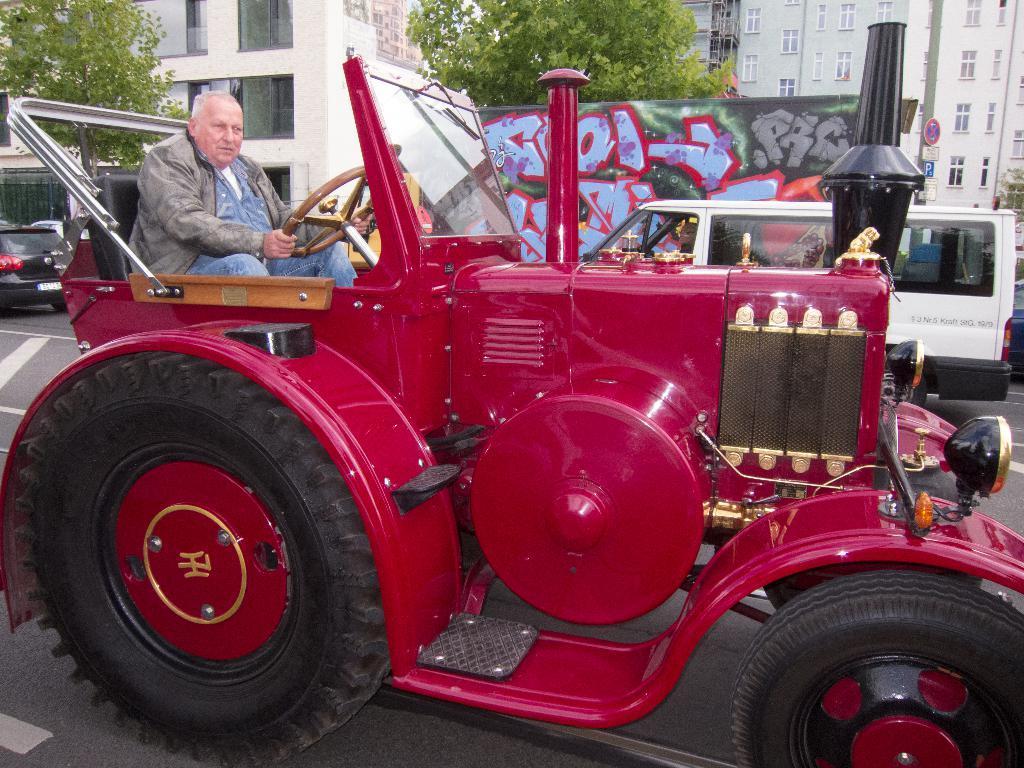Describe this image in one or two sentences. There is a man sitting and holding a steering of a red color vehicle. In the back there are vehicles. There is a road. Also there is a poster with graffiti. In the background there are trees and buildings with windows. 